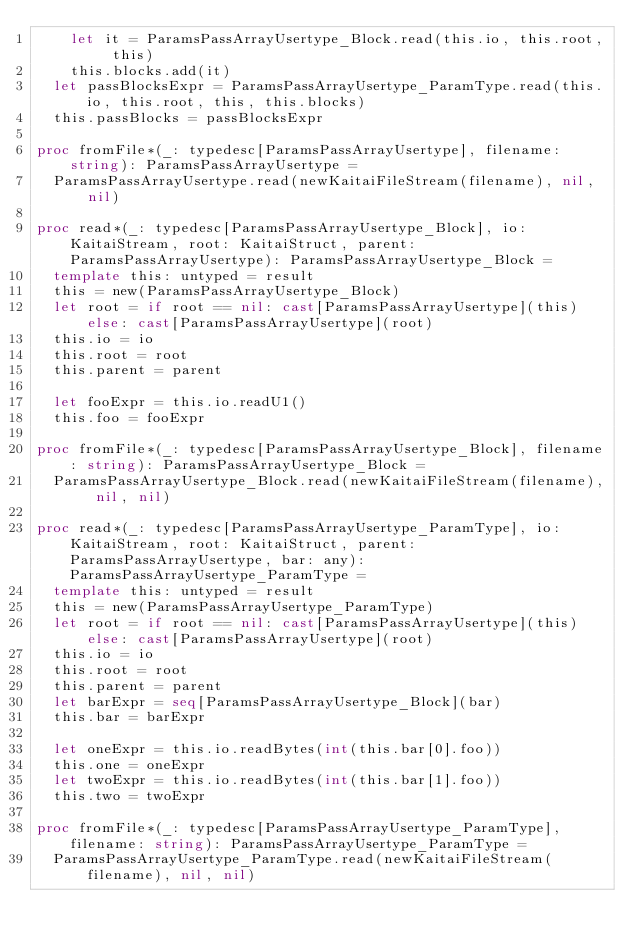Convert code to text. <code><loc_0><loc_0><loc_500><loc_500><_Nim_>    let it = ParamsPassArrayUsertype_Block.read(this.io, this.root, this)
    this.blocks.add(it)
  let passBlocksExpr = ParamsPassArrayUsertype_ParamType.read(this.io, this.root, this, this.blocks)
  this.passBlocks = passBlocksExpr

proc fromFile*(_: typedesc[ParamsPassArrayUsertype], filename: string): ParamsPassArrayUsertype =
  ParamsPassArrayUsertype.read(newKaitaiFileStream(filename), nil, nil)

proc read*(_: typedesc[ParamsPassArrayUsertype_Block], io: KaitaiStream, root: KaitaiStruct, parent: ParamsPassArrayUsertype): ParamsPassArrayUsertype_Block =
  template this: untyped = result
  this = new(ParamsPassArrayUsertype_Block)
  let root = if root == nil: cast[ParamsPassArrayUsertype](this) else: cast[ParamsPassArrayUsertype](root)
  this.io = io
  this.root = root
  this.parent = parent

  let fooExpr = this.io.readU1()
  this.foo = fooExpr

proc fromFile*(_: typedesc[ParamsPassArrayUsertype_Block], filename: string): ParamsPassArrayUsertype_Block =
  ParamsPassArrayUsertype_Block.read(newKaitaiFileStream(filename), nil, nil)

proc read*(_: typedesc[ParamsPassArrayUsertype_ParamType], io: KaitaiStream, root: KaitaiStruct, parent: ParamsPassArrayUsertype, bar: any): ParamsPassArrayUsertype_ParamType =
  template this: untyped = result
  this = new(ParamsPassArrayUsertype_ParamType)
  let root = if root == nil: cast[ParamsPassArrayUsertype](this) else: cast[ParamsPassArrayUsertype](root)
  this.io = io
  this.root = root
  this.parent = parent
  let barExpr = seq[ParamsPassArrayUsertype_Block](bar)
  this.bar = barExpr

  let oneExpr = this.io.readBytes(int(this.bar[0].foo))
  this.one = oneExpr
  let twoExpr = this.io.readBytes(int(this.bar[1].foo))
  this.two = twoExpr

proc fromFile*(_: typedesc[ParamsPassArrayUsertype_ParamType], filename: string): ParamsPassArrayUsertype_ParamType =
  ParamsPassArrayUsertype_ParamType.read(newKaitaiFileStream(filename), nil, nil)

</code> 